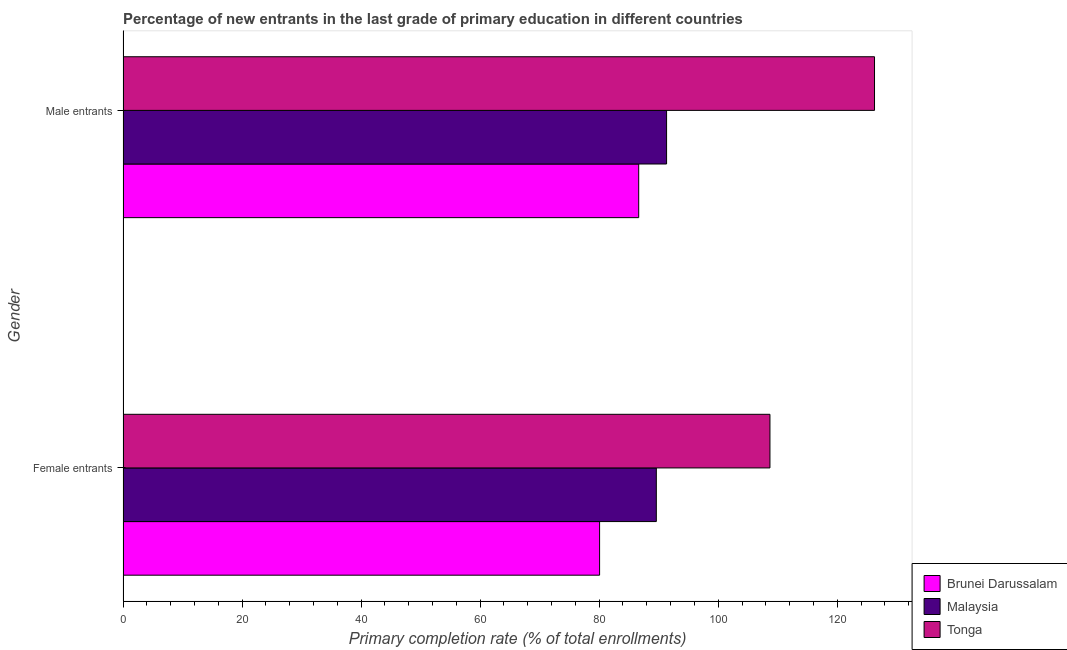How many bars are there on the 2nd tick from the bottom?
Your answer should be compact. 3. What is the label of the 2nd group of bars from the top?
Keep it short and to the point. Female entrants. What is the primary completion rate of male entrants in Tonga?
Ensure brevity in your answer.  126.26. Across all countries, what is the maximum primary completion rate of male entrants?
Offer a terse response. 126.26. Across all countries, what is the minimum primary completion rate of male entrants?
Offer a very short reply. 86.64. In which country was the primary completion rate of male entrants maximum?
Make the answer very short. Tonga. In which country was the primary completion rate of male entrants minimum?
Offer a terse response. Brunei Darussalam. What is the total primary completion rate of female entrants in the graph?
Ensure brevity in your answer.  278.37. What is the difference between the primary completion rate of female entrants in Brunei Darussalam and that in Malaysia?
Ensure brevity in your answer.  -9.53. What is the difference between the primary completion rate of male entrants in Brunei Darussalam and the primary completion rate of female entrants in Malaysia?
Give a very brief answer. -2.96. What is the average primary completion rate of male entrants per country?
Keep it short and to the point. 101.41. What is the difference between the primary completion rate of male entrants and primary completion rate of female entrants in Tonga?
Your answer should be very brief. 17.57. In how many countries, is the primary completion rate of female entrants greater than 20 %?
Ensure brevity in your answer.  3. What is the ratio of the primary completion rate of male entrants in Tonga to that in Malaysia?
Ensure brevity in your answer.  1.38. Is the primary completion rate of male entrants in Tonga less than that in Brunei Darussalam?
Offer a terse response. No. What does the 2nd bar from the top in Female entrants represents?
Your answer should be very brief. Malaysia. What does the 3rd bar from the bottom in Male entrants represents?
Your answer should be very brief. Tonga. How many bars are there?
Keep it short and to the point. 6. Are all the bars in the graph horizontal?
Offer a terse response. Yes. What is the difference between two consecutive major ticks on the X-axis?
Your response must be concise. 20. Are the values on the major ticks of X-axis written in scientific E-notation?
Your response must be concise. No. Does the graph contain any zero values?
Make the answer very short. No. Does the graph contain grids?
Make the answer very short. No. What is the title of the graph?
Offer a very short reply. Percentage of new entrants in the last grade of primary education in different countries. What is the label or title of the X-axis?
Your response must be concise. Primary completion rate (% of total enrollments). What is the Primary completion rate (% of total enrollments) of Brunei Darussalam in Female entrants?
Give a very brief answer. 80.07. What is the Primary completion rate (% of total enrollments) of Malaysia in Female entrants?
Provide a short and direct response. 89.6. What is the Primary completion rate (% of total enrollments) of Tonga in Female entrants?
Keep it short and to the point. 108.69. What is the Primary completion rate (% of total enrollments) in Brunei Darussalam in Male entrants?
Your answer should be compact. 86.64. What is the Primary completion rate (% of total enrollments) in Malaysia in Male entrants?
Keep it short and to the point. 91.32. What is the Primary completion rate (% of total enrollments) in Tonga in Male entrants?
Offer a terse response. 126.26. Across all Gender, what is the maximum Primary completion rate (% of total enrollments) in Brunei Darussalam?
Your answer should be very brief. 86.64. Across all Gender, what is the maximum Primary completion rate (% of total enrollments) in Malaysia?
Provide a short and direct response. 91.32. Across all Gender, what is the maximum Primary completion rate (% of total enrollments) in Tonga?
Your response must be concise. 126.26. Across all Gender, what is the minimum Primary completion rate (% of total enrollments) in Brunei Darussalam?
Make the answer very short. 80.07. Across all Gender, what is the minimum Primary completion rate (% of total enrollments) in Malaysia?
Your response must be concise. 89.6. Across all Gender, what is the minimum Primary completion rate (% of total enrollments) in Tonga?
Your response must be concise. 108.69. What is the total Primary completion rate (% of total enrollments) in Brunei Darussalam in the graph?
Offer a terse response. 166.71. What is the total Primary completion rate (% of total enrollments) of Malaysia in the graph?
Your answer should be compact. 180.93. What is the total Primary completion rate (% of total enrollments) of Tonga in the graph?
Your response must be concise. 234.95. What is the difference between the Primary completion rate (% of total enrollments) of Brunei Darussalam in Female entrants and that in Male entrants?
Offer a terse response. -6.57. What is the difference between the Primary completion rate (% of total enrollments) of Malaysia in Female entrants and that in Male entrants?
Offer a very short reply. -1.72. What is the difference between the Primary completion rate (% of total enrollments) in Tonga in Female entrants and that in Male entrants?
Your response must be concise. -17.57. What is the difference between the Primary completion rate (% of total enrollments) in Brunei Darussalam in Female entrants and the Primary completion rate (% of total enrollments) in Malaysia in Male entrants?
Give a very brief answer. -11.25. What is the difference between the Primary completion rate (% of total enrollments) in Brunei Darussalam in Female entrants and the Primary completion rate (% of total enrollments) in Tonga in Male entrants?
Your response must be concise. -46.19. What is the difference between the Primary completion rate (% of total enrollments) in Malaysia in Female entrants and the Primary completion rate (% of total enrollments) in Tonga in Male entrants?
Keep it short and to the point. -36.66. What is the average Primary completion rate (% of total enrollments) of Brunei Darussalam per Gender?
Your answer should be compact. 83.36. What is the average Primary completion rate (% of total enrollments) in Malaysia per Gender?
Ensure brevity in your answer.  90.46. What is the average Primary completion rate (% of total enrollments) in Tonga per Gender?
Offer a very short reply. 117.48. What is the difference between the Primary completion rate (% of total enrollments) in Brunei Darussalam and Primary completion rate (% of total enrollments) in Malaysia in Female entrants?
Provide a succinct answer. -9.53. What is the difference between the Primary completion rate (% of total enrollments) in Brunei Darussalam and Primary completion rate (% of total enrollments) in Tonga in Female entrants?
Provide a succinct answer. -28.62. What is the difference between the Primary completion rate (% of total enrollments) in Malaysia and Primary completion rate (% of total enrollments) in Tonga in Female entrants?
Offer a terse response. -19.09. What is the difference between the Primary completion rate (% of total enrollments) of Brunei Darussalam and Primary completion rate (% of total enrollments) of Malaysia in Male entrants?
Your response must be concise. -4.68. What is the difference between the Primary completion rate (% of total enrollments) of Brunei Darussalam and Primary completion rate (% of total enrollments) of Tonga in Male entrants?
Your answer should be very brief. -39.62. What is the difference between the Primary completion rate (% of total enrollments) in Malaysia and Primary completion rate (% of total enrollments) in Tonga in Male entrants?
Give a very brief answer. -34.93. What is the ratio of the Primary completion rate (% of total enrollments) in Brunei Darussalam in Female entrants to that in Male entrants?
Ensure brevity in your answer.  0.92. What is the ratio of the Primary completion rate (% of total enrollments) in Malaysia in Female entrants to that in Male entrants?
Give a very brief answer. 0.98. What is the ratio of the Primary completion rate (% of total enrollments) of Tonga in Female entrants to that in Male entrants?
Offer a terse response. 0.86. What is the difference between the highest and the second highest Primary completion rate (% of total enrollments) of Brunei Darussalam?
Provide a short and direct response. 6.57. What is the difference between the highest and the second highest Primary completion rate (% of total enrollments) in Malaysia?
Your answer should be compact. 1.72. What is the difference between the highest and the second highest Primary completion rate (% of total enrollments) of Tonga?
Keep it short and to the point. 17.57. What is the difference between the highest and the lowest Primary completion rate (% of total enrollments) in Brunei Darussalam?
Provide a short and direct response. 6.57. What is the difference between the highest and the lowest Primary completion rate (% of total enrollments) of Malaysia?
Ensure brevity in your answer.  1.72. What is the difference between the highest and the lowest Primary completion rate (% of total enrollments) of Tonga?
Provide a succinct answer. 17.57. 